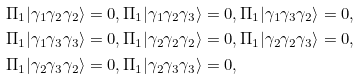Convert formula to latex. <formula><loc_0><loc_0><loc_500><loc_500>& \Pi _ { 1 } | \gamma _ { 1 } \gamma _ { 2 } \gamma _ { 2 } \rangle = 0 , \Pi _ { 1 } | \gamma _ { 1 } \gamma _ { 2 } \gamma _ { 3 } \rangle = 0 , \Pi _ { 1 } | \gamma _ { 1 } \gamma _ { 3 } \gamma _ { 2 } \rangle = 0 , \\ & \Pi _ { 1 } | \gamma _ { 1 } \gamma _ { 3 } \gamma _ { 3 } \rangle = 0 , \Pi _ { 1 } | \gamma _ { 2 } \gamma _ { 2 } \gamma _ { 2 } \rangle = 0 , \Pi _ { 1 } | \gamma _ { 2 } \gamma _ { 2 } \gamma _ { 3 } \rangle = 0 , \\ & \Pi _ { 1 } | \gamma _ { 2 } \gamma _ { 3 } \gamma _ { 2 } \rangle = 0 , \Pi _ { 1 } | \gamma _ { 2 } \gamma _ { 3 } \gamma _ { 3 } \rangle = 0 ,</formula> 